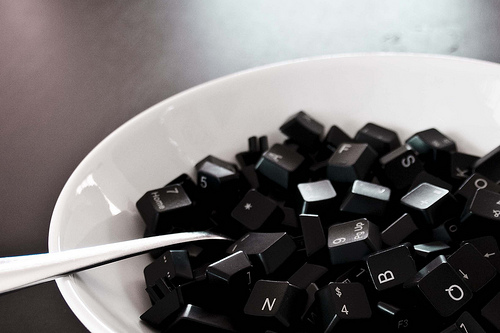<image>
Is the keyboard keys in the bowl? Yes. The keyboard keys is contained within or inside the bowl, showing a containment relationship. 